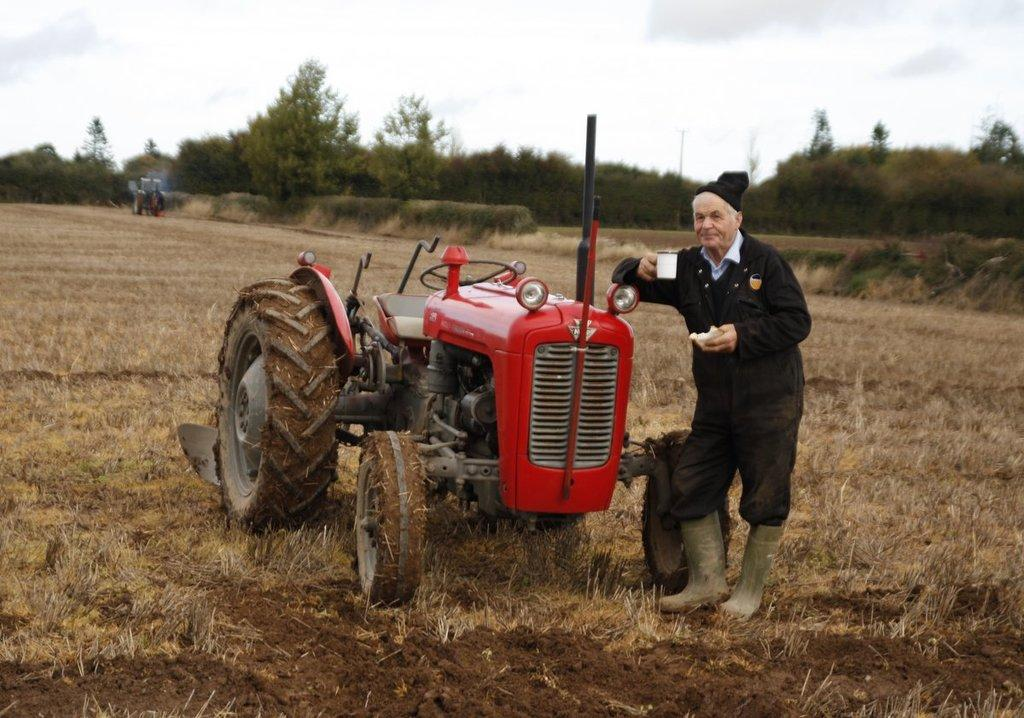What is the main subject in the center of the image? There is a tractor in the center of the image. Who is present on the right side of the image? There is a man standing on the right side of the image. What is the man holding in his hand? The man is holding a cup in his hand. What can be seen in the background of the image? There are trees, a vehicle, grass, and the sky visible in the background of the image. What type of advertisement can be seen on the side of the tractor in the image? There is no advertisement present on the side of the tractor in the image. What street is the tractor driving on in the image? The image does not show a street, and the tractor is not in motion. 